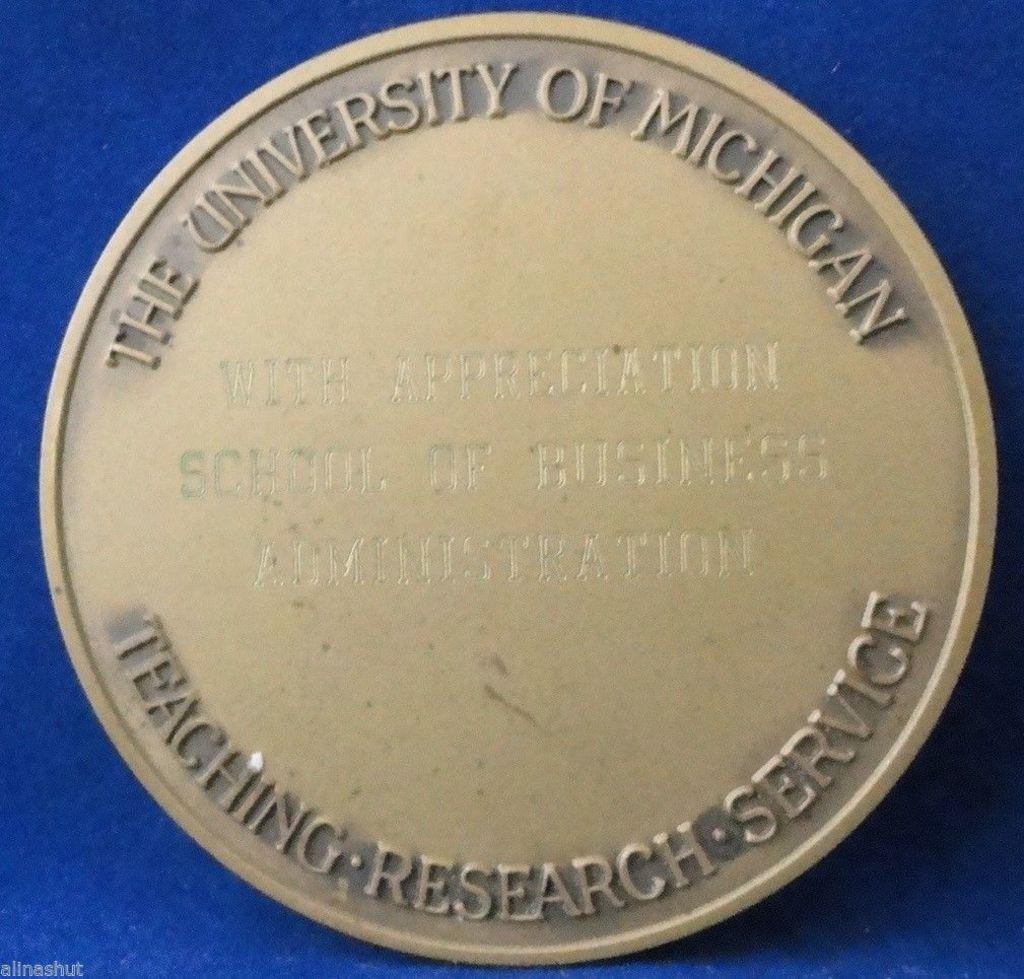What university is listed?
Your answer should be compact. University of michigan. 